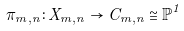<formula> <loc_0><loc_0><loc_500><loc_500>\pi _ { m , n } \colon X _ { m , n } \rightarrow C _ { m , n } \cong \mathbb { P } ^ { 1 }</formula> 